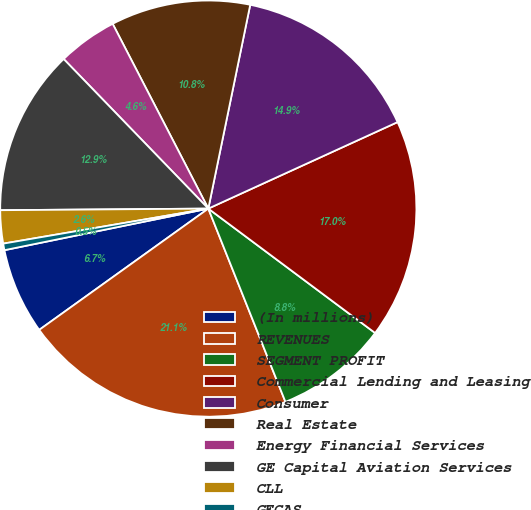Convert chart to OTSL. <chart><loc_0><loc_0><loc_500><loc_500><pie_chart><fcel>(In millions)<fcel>REVENUES<fcel>SEGMENT PROFIT<fcel>Commercial Lending and Leasing<fcel>Consumer<fcel>Real Estate<fcel>Energy Financial Services<fcel>GE Capital Aviation Services<fcel>CLL<fcel>GECAS<nl><fcel>6.7%<fcel>21.14%<fcel>8.76%<fcel>17.02%<fcel>14.95%<fcel>10.83%<fcel>4.63%<fcel>12.89%<fcel>2.57%<fcel>0.51%<nl></chart> 